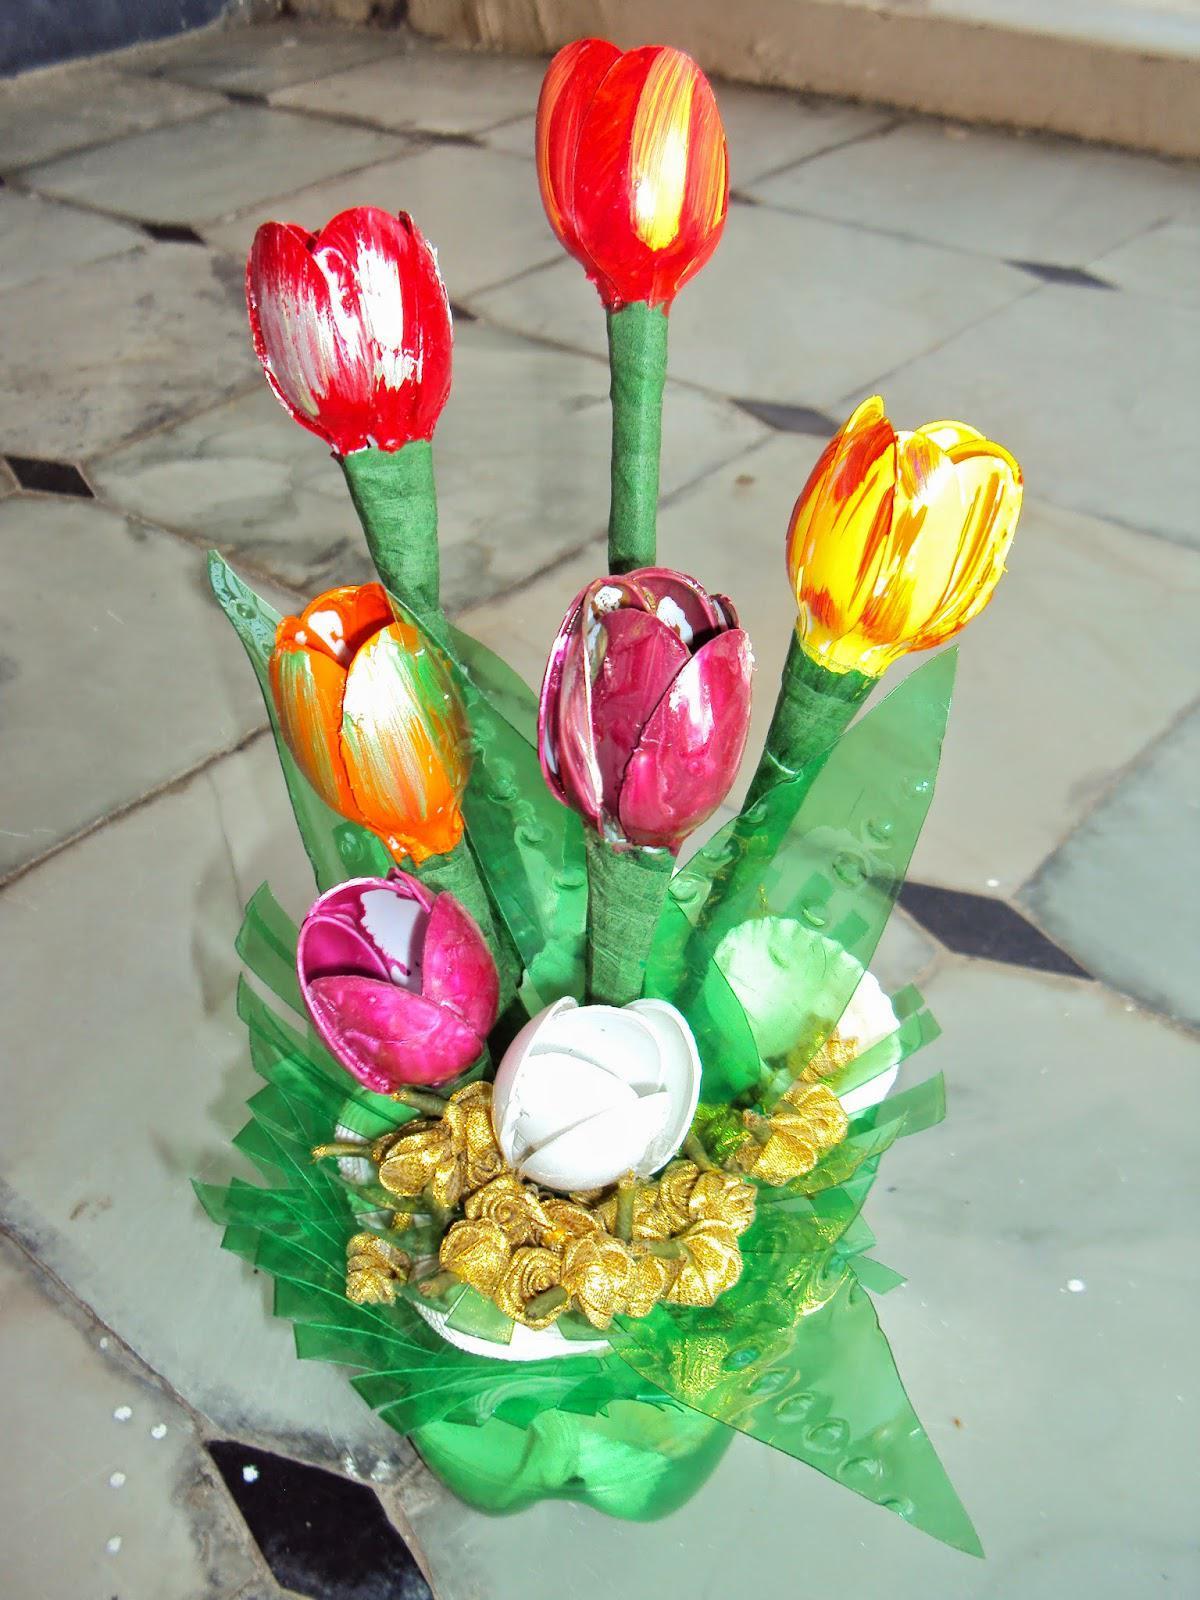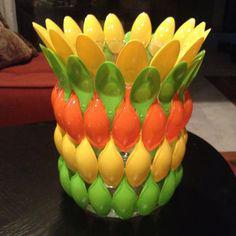The first image is the image on the left, the second image is the image on the right. For the images shown, is this caption "In one of the images, there are more than one pots with plantlife in them." true? Answer yes or no. No. The first image is the image on the left, the second image is the image on the right. Examine the images to the left and right. Is the description "One image shows at leat four faux flowers of different colors, and the other image shows a vase made out of stacked layers of oval shapes that are actually plastic spoons." accurate? Answer yes or no. Yes. 